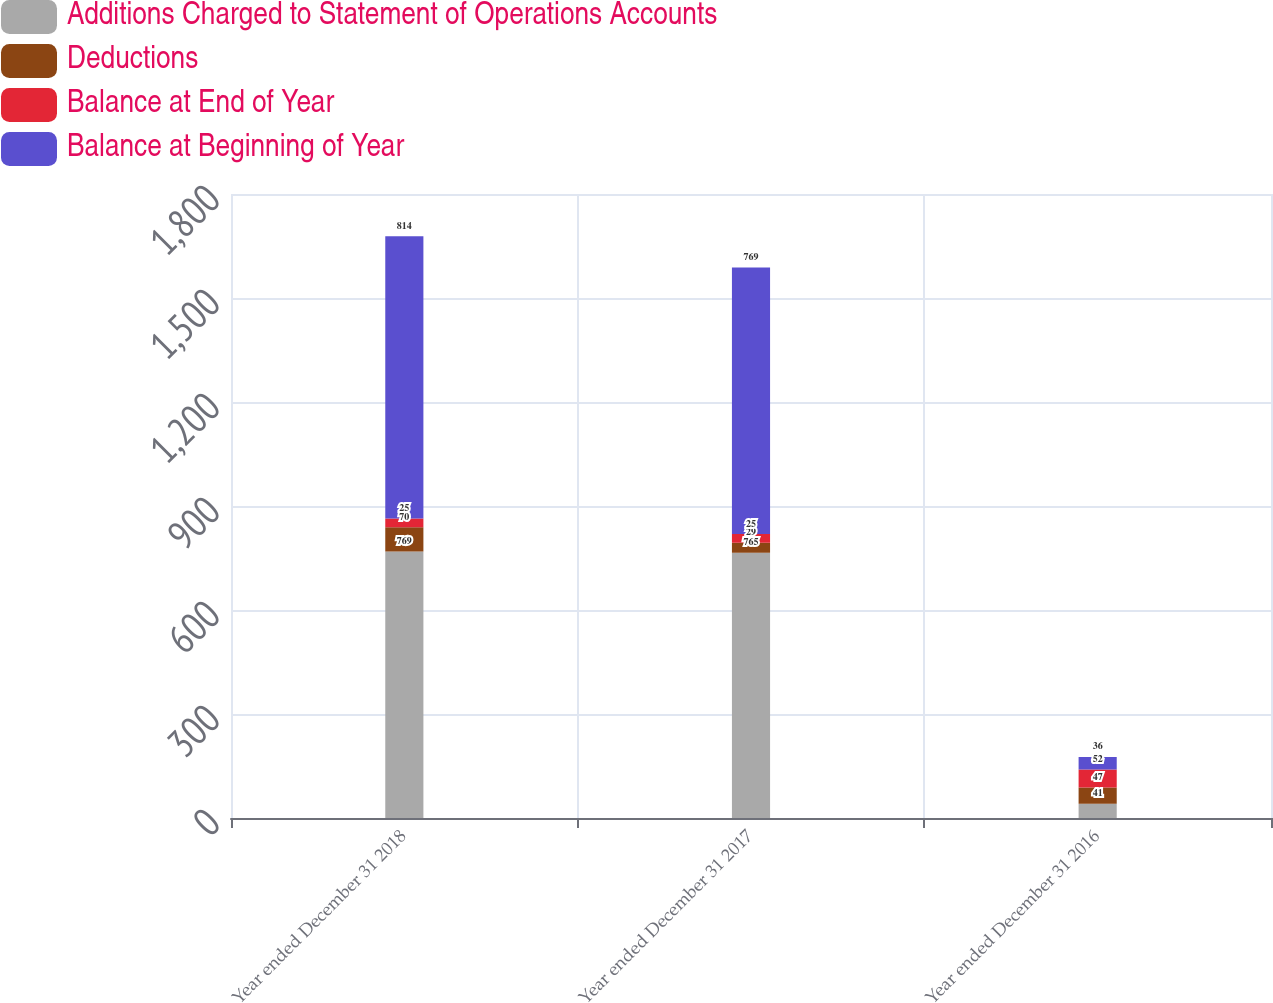Convert chart. <chart><loc_0><loc_0><loc_500><loc_500><stacked_bar_chart><ecel><fcel>Year ended December 31 2018<fcel>Year ended December 31 2017<fcel>Year ended December 31 2016<nl><fcel>Additions Charged to Statement of Operations Accounts<fcel>769<fcel>765<fcel>41<nl><fcel>Deductions<fcel>70<fcel>29<fcel>47<nl><fcel>Balance at End of Year<fcel>25<fcel>25<fcel>52<nl><fcel>Balance at Beginning of Year<fcel>814<fcel>769<fcel>36<nl></chart> 